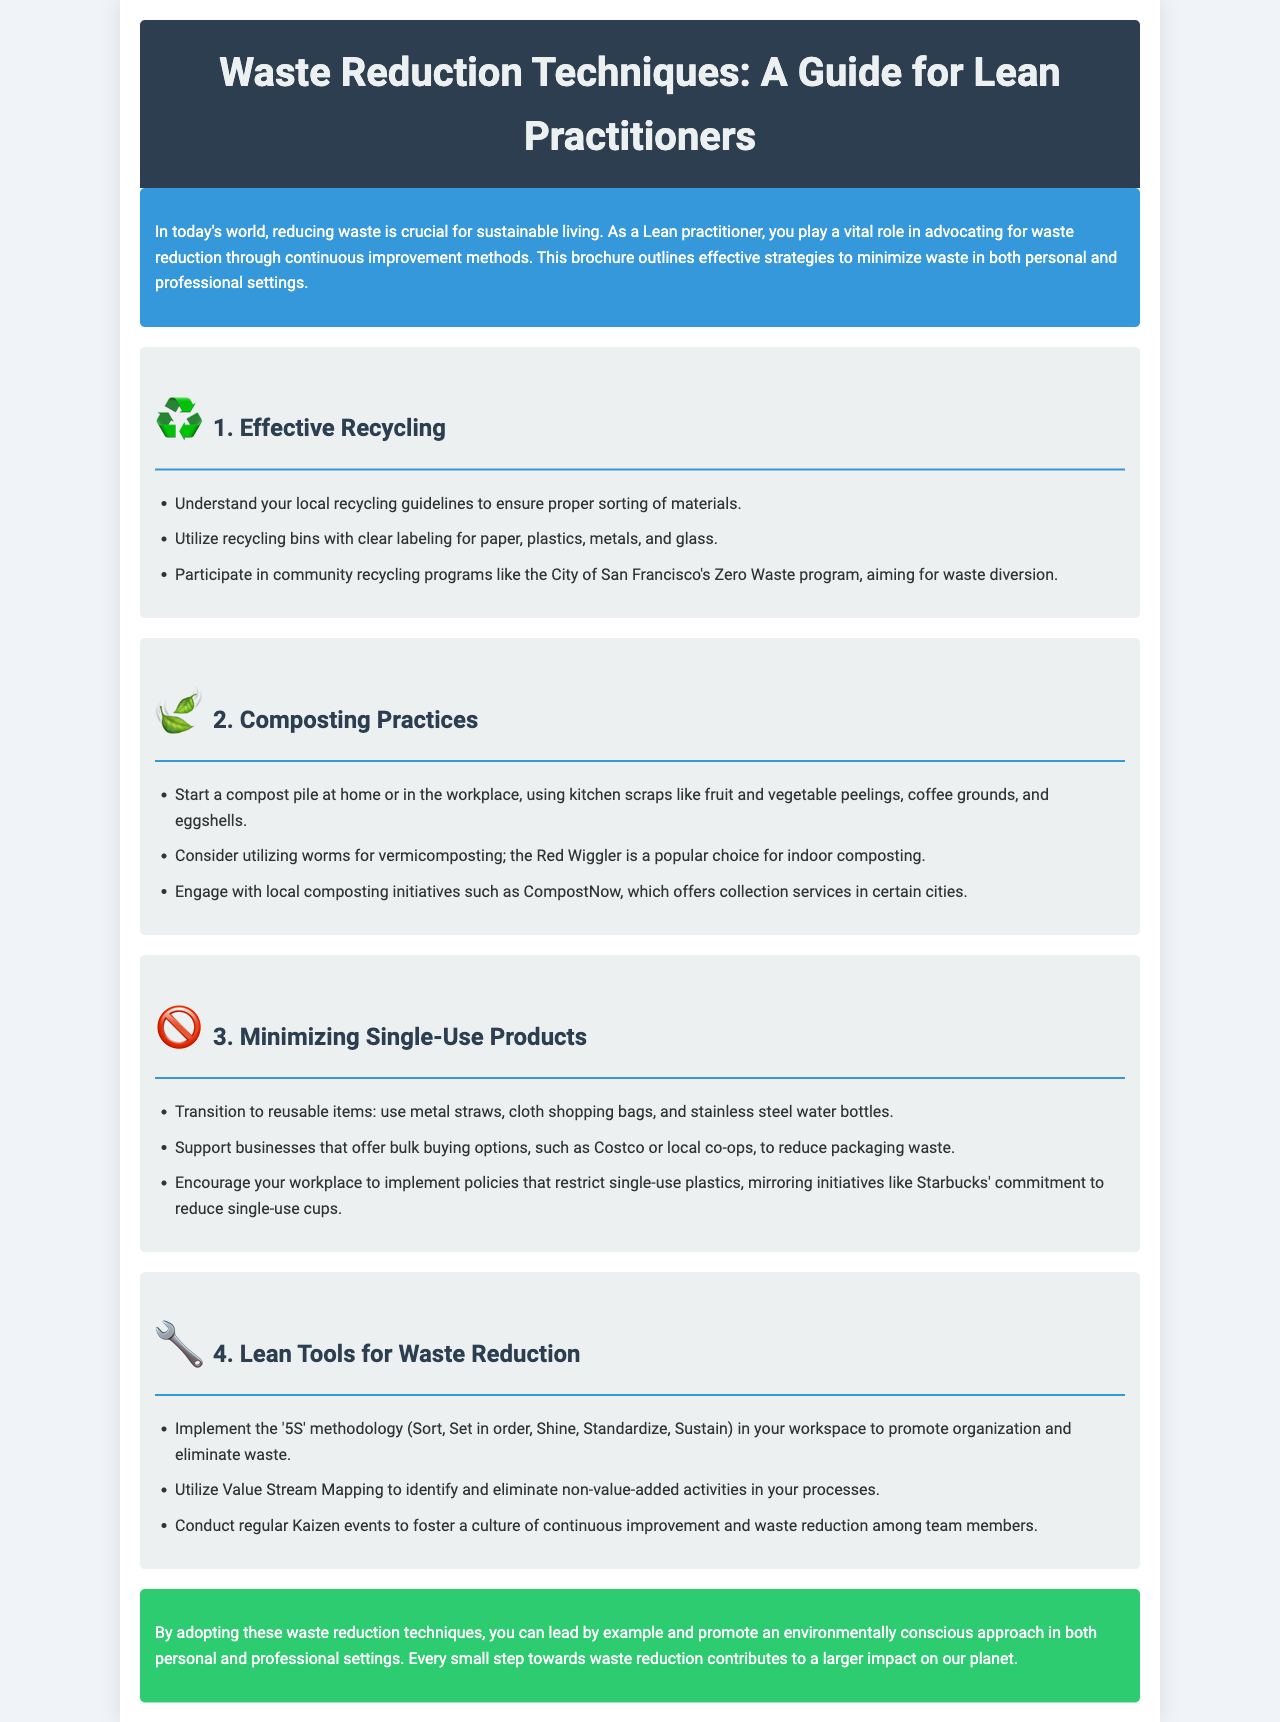What is the title of the brochure? The title is prominently displayed at the top of the brochure, showcasing its focus on waste reduction techniques for Lean practitioners.
Answer: Waste Reduction Techniques: A Guide for Lean Practitioners What icon represents Effective Recycling? The icon used for this section visually symbolizes recycling, making it easily identifiable.
Answer: ♻️ What initiative is mentioned for community recycling? This program highlights a specific effort towards waste diversion at the community level.
Answer: City of San Francisco's Zero Waste program What is one item to compost according to the brochure? This item is listed as suitable kitchen waste for composting, contributing to waste reduction.
Answer: Fruit and vegetable peelings What methodology is recommended for workspace organization? This methodology is a key Lean practice to enhance efficiency and reduce waste in the workplace.
Answer: 5S What is the main color scheme of the conclusion section? The color chosen for the conclusion contrasts with the rest of the brochure, drawing attention to the final message.
Answer: Green What type of products should be minimized according to the brochure? This concept encourages a shift away from disposable items toward more sustainable options.
Answer: Single-use products What tool is used to identify non-value-added activities? This tool is integral to Lean practices for continuous improvement and waste reduction.
Answer: Value Stream Mapping What practice involves starting a compost pile? This practice is a foundational step to minimize organic waste and promote sustainability at home or work.
Answer: Composting 